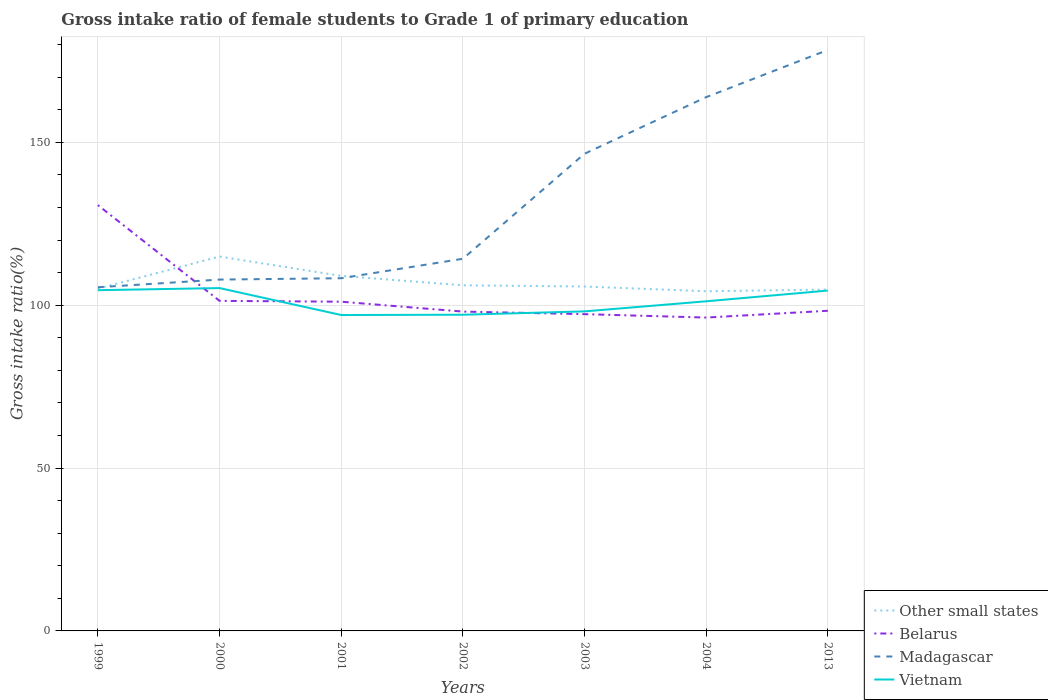How many different coloured lines are there?
Provide a succinct answer. 4. Does the line corresponding to Belarus intersect with the line corresponding to Other small states?
Make the answer very short. Yes. Across all years, what is the maximum gross intake ratio in Madagascar?
Offer a very short reply. 105.5. What is the total gross intake ratio in Vietnam in the graph?
Offer a very short reply. -4.12. What is the difference between the highest and the second highest gross intake ratio in Vietnam?
Your answer should be compact. 8.27. How many years are there in the graph?
Your response must be concise. 7. What is the difference between two consecutive major ticks on the Y-axis?
Offer a terse response. 50. Are the values on the major ticks of Y-axis written in scientific E-notation?
Keep it short and to the point. No. How many legend labels are there?
Keep it short and to the point. 4. What is the title of the graph?
Keep it short and to the point. Gross intake ratio of female students to Grade 1 of primary education. Does "Macao" appear as one of the legend labels in the graph?
Provide a short and direct response. No. What is the label or title of the X-axis?
Provide a short and direct response. Years. What is the label or title of the Y-axis?
Keep it short and to the point. Gross intake ratio(%). What is the Gross intake ratio(%) of Other small states in 1999?
Your answer should be very brief. 105.07. What is the Gross intake ratio(%) in Belarus in 1999?
Provide a succinct answer. 130.71. What is the Gross intake ratio(%) in Madagascar in 1999?
Give a very brief answer. 105.5. What is the Gross intake ratio(%) in Vietnam in 1999?
Your answer should be compact. 104.6. What is the Gross intake ratio(%) of Other small states in 2000?
Offer a very short reply. 114.93. What is the Gross intake ratio(%) in Belarus in 2000?
Give a very brief answer. 101.32. What is the Gross intake ratio(%) of Madagascar in 2000?
Provide a short and direct response. 107.85. What is the Gross intake ratio(%) of Vietnam in 2000?
Ensure brevity in your answer.  105.24. What is the Gross intake ratio(%) in Other small states in 2001?
Your answer should be very brief. 108.98. What is the Gross intake ratio(%) of Belarus in 2001?
Your answer should be compact. 101.06. What is the Gross intake ratio(%) in Madagascar in 2001?
Ensure brevity in your answer.  108.27. What is the Gross intake ratio(%) in Vietnam in 2001?
Your answer should be very brief. 96.98. What is the Gross intake ratio(%) of Other small states in 2002?
Your answer should be compact. 106.1. What is the Gross intake ratio(%) in Belarus in 2002?
Offer a very short reply. 98.03. What is the Gross intake ratio(%) of Madagascar in 2002?
Offer a very short reply. 114.24. What is the Gross intake ratio(%) of Vietnam in 2002?
Ensure brevity in your answer.  97.06. What is the Gross intake ratio(%) in Other small states in 2003?
Ensure brevity in your answer.  105.73. What is the Gross intake ratio(%) of Belarus in 2003?
Provide a short and direct response. 97.24. What is the Gross intake ratio(%) of Madagascar in 2003?
Give a very brief answer. 146.48. What is the Gross intake ratio(%) of Vietnam in 2003?
Your answer should be very brief. 98.09. What is the Gross intake ratio(%) of Other small states in 2004?
Ensure brevity in your answer.  104.27. What is the Gross intake ratio(%) of Belarus in 2004?
Ensure brevity in your answer.  96.19. What is the Gross intake ratio(%) of Madagascar in 2004?
Offer a very short reply. 163.85. What is the Gross intake ratio(%) of Vietnam in 2004?
Give a very brief answer. 101.19. What is the Gross intake ratio(%) of Other small states in 2013?
Ensure brevity in your answer.  104.79. What is the Gross intake ratio(%) in Belarus in 2013?
Provide a short and direct response. 98.28. What is the Gross intake ratio(%) in Madagascar in 2013?
Your answer should be very brief. 178.34. What is the Gross intake ratio(%) of Vietnam in 2013?
Offer a terse response. 104.48. Across all years, what is the maximum Gross intake ratio(%) of Other small states?
Ensure brevity in your answer.  114.93. Across all years, what is the maximum Gross intake ratio(%) in Belarus?
Your answer should be compact. 130.71. Across all years, what is the maximum Gross intake ratio(%) in Madagascar?
Your answer should be very brief. 178.34. Across all years, what is the maximum Gross intake ratio(%) in Vietnam?
Provide a short and direct response. 105.24. Across all years, what is the minimum Gross intake ratio(%) of Other small states?
Ensure brevity in your answer.  104.27. Across all years, what is the minimum Gross intake ratio(%) in Belarus?
Provide a succinct answer. 96.19. Across all years, what is the minimum Gross intake ratio(%) of Madagascar?
Keep it short and to the point. 105.5. Across all years, what is the minimum Gross intake ratio(%) of Vietnam?
Make the answer very short. 96.98. What is the total Gross intake ratio(%) in Other small states in the graph?
Your answer should be compact. 749.86. What is the total Gross intake ratio(%) of Belarus in the graph?
Offer a terse response. 722.84. What is the total Gross intake ratio(%) in Madagascar in the graph?
Offer a very short reply. 924.54. What is the total Gross intake ratio(%) in Vietnam in the graph?
Make the answer very short. 707.64. What is the difference between the Gross intake ratio(%) of Other small states in 1999 and that in 2000?
Offer a very short reply. -9.86. What is the difference between the Gross intake ratio(%) in Belarus in 1999 and that in 2000?
Provide a succinct answer. 29.39. What is the difference between the Gross intake ratio(%) in Madagascar in 1999 and that in 2000?
Your answer should be very brief. -2.36. What is the difference between the Gross intake ratio(%) in Vietnam in 1999 and that in 2000?
Offer a very short reply. -0.65. What is the difference between the Gross intake ratio(%) of Other small states in 1999 and that in 2001?
Your answer should be very brief. -3.91. What is the difference between the Gross intake ratio(%) of Belarus in 1999 and that in 2001?
Provide a short and direct response. 29.65. What is the difference between the Gross intake ratio(%) of Madagascar in 1999 and that in 2001?
Keep it short and to the point. -2.78. What is the difference between the Gross intake ratio(%) in Vietnam in 1999 and that in 2001?
Provide a short and direct response. 7.62. What is the difference between the Gross intake ratio(%) of Other small states in 1999 and that in 2002?
Give a very brief answer. -1.04. What is the difference between the Gross intake ratio(%) of Belarus in 1999 and that in 2002?
Your response must be concise. 32.69. What is the difference between the Gross intake ratio(%) in Madagascar in 1999 and that in 2002?
Make the answer very short. -8.75. What is the difference between the Gross intake ratio(%) in Vietnam in 1999 and that in 2002?
Offer a very short reply. 7.54. What is the difference between the Gross intake ratio(%) of Other small states in 1999 and that in 2003?
Ensure brevity in your answer.  -0.66. What is the difference between the Gross intake ratio(%) in Belarus in 1999 and that in 2003?
Give a very brief answer. 33.47. What is the difference between the Gross intake ratio(%) in Madagascar in 1999 and that in 2003?
Provide a short and direct response. -40.98. What is the difference between the Gross intake ratio(%) of Vietnam in 1999 and that in 2003?
Give a very brief answer. 6.51. What is the difference between the Gross intake ratio(%) of Other small states in 1999 and that in 2004?
Provide a succinct answer. 0.8. What is the difference between the Gross intake ratio(%) of Belarus in 1999 and that in 2004?
Your answer should be compact. 34.52. What is the difference between the Gross intake ratio(%) of Madagascar in 1999 and that in 2004?
Provide a short and direct response. -58.36. What is the difference between the Gross intake ratio(%) of Vietnam in 1999 and that in 2004?
Provide a short and direct response. 3.41. What is the difference between the Gross intake ratio(%) of Other small states in 1999 and that in 2013?
Ensure brevity in your answer.  0.28. What is the difference between the Gross intake ratio(%) in Belarus in 1999 and that in 2013?
Provide a short and direct response. 32.43. What is the difference between the Gross intake ratio(%) in Madagascar in 1999 and that in 2013?
Make the answer very short. -72.85. What is the difference between the Gross intake ratio(%) in Vietnam in 1999 and that in 2013?
Give a very brief answer. 0.12. What is the difference between the Gross intake ratio(%) of Other small states in 2000 and that in 2001?
Provide a succinct answer. 5.95. What is the difference between the Gross intake ratio(%) of Belarus in 2000 and that in 2001?
Give a very brief answer. 0.26. What is the difference between the Gross intake ratio(%) of Madagascar in 2000 and that in 2001?
Keep it short and to the point. -0.42. What is the difference between the Gross intake ratio(%) in Vietnam in 2000 and that in 2001?
Give a very brief answer. 8.27. What is the difference between the Gross intake ratio(%) of Other small states in 2000 and that in 2002?
Offer a very short reply. 8.83. What is the difference between the Gross intake ratio(%) in Belarus in 2000 and that in 2002?
Your answer should be very brief. 3.29. What is the difference between the Gross intake ratio(%) of Madagascar in 2000 and that in 2002?
Your answer should be very brief. -6.39. What is the difference between the Gross intake ratio(%) of Vietnam in 2000 and that in 2002?
Offer a very short reply. 8.18. What is the difference between the Gross intake ratio(%) of Other small states in 2000 and that in 2003?
Your response must be concise. 9.2. What is the difference between the Gross intake ratio(%) of Belarus in 2000 and that in 2003?
Your answer should be very brief. 4.08. What is the difference between the Gross intake ratio(%) of Madagascar in 2000 and that in 2003?
Your answer should be compact. -38.63. What is the difference between the Gross intake ratio(%) of Vietnam in 2000 and that in 2003?
Make the answer very short. 7.15. What is the difference between the Gross intake ratio(%) of Other small states in 2000 and that in 2004?
Offer a very short reply. 10.66. What is the difference between the Gross intake ratio(%) in Belarus in 2000 and that in 2004?
Offer a terse response. 5.13. What is the difference between the Gross intake ratio(%) of Madagascar in 2000 and that in 2004?
Give a very brief answer. -56. What is the difference between the Gross intake ratio(%) in Vietnam in 2000 and that in 2004?
Ensure brevity in your answer.  4.06. What is the difference between the Gross intake ratio(%) in Other small states in 2000 and that in 2013?
Ensure brevity in your answer.  10.14. What is the difference between the Gross intake ratio(%) of Belarus in 2000 and that in 2013?
Offer a terse response. 3.04. What is the difference between the Gross intake ratio(%) in Madagascar in 2000 and that in 2013?
Offer a terse response. -70.49. What is the difference between the Gross intake ratio(%) of Vietnam in 2000 and that in 2013?
Provide a short and direct response. 0.76. What is the difference between the Gross intake ratio(%) of Other small states in 2001 and that in 2002?
Give a very brief answer. 2.88. What is the difference between the Gross intake ratio(%) in Belarus in 2001 and that in 2002?
Give a very brief answer. 3.03. What is the difference between the Gross intake ratio(%) in Madagascar in 2001 and that in 2002?
Make the answer very short. -5.97. What is the difference between the Gross intake ratio(%) of Vietnam in 2001 and that in 2002?
Offer a terse response. -0.08. What is the difference between the Gross intake ratio(%) of Other small states in 2001 and that in 2003?
Your response must be concise. 3.25. What is the difference between the Gross intake ratio(%) in Belarus in 2001 and that in 2003?
Keep it short and to the point. 3.82. What is the difference between the Gross intake ratio(%) of Madagascar in 2001 and that in 2003?
Give a very brief answer. -38.21. What is the difference between the Gross intake ratio(%) in Vietnam in 2001 and that in 2003?
Your answer should be very brief. -1.11. What is the difference between the Gross intake ratio(%) of Other small states in 2001 and that in 2004?
Keep it short and to the point. 4.71. What is the difference between the Gross intake ratio(%) of Belarus in 2001 and that in 2004?
Your answer should be compact. 4.87. What is the difference between the Gross intake ratio(%) in Madagascar in 2001 and that in 2004?
Your answer should be compact. -55.58. What is the difference between the Gross intake ratio(%) in Vietnam in 2001 and that in 2004?
Give a very brief answer. -4.21. What is the difference between the Gross intake ratio(%) of Other small states in 2001 and that in 2013?
Keep it short and to the point. 4.19. What is the difference between the Gross intake ratio(%) of Belarus in 2001 and that in 2013?
Provide a succinct answer. 2.78. What is the difference between the Gross intake ratio(%) in Madagascar in 2001 and that in 2013?
Offer a very short reply. -70.07. What is the difference between the Gross intake ratio(%) in Vietnam in 2001 and that in 2013?
Give a very brief answer. -7.5. What is the difference between the Gross intake ratio(%) of Other small states in 2002 and that in 2003?
Provide a short and direct response. 0.38. What is the difference between the Gross intake ratio(%) of Belarus in 2002 and that in 2003?
Your answer should be very brief. 0.79. What is the difference between the Gross intake ratio(%) of Madagascar in 2002 and that in 2003?
Your response must be concise. -32.24. What is the difference between the Gross intake ratio(%) of Vietnam in 2002 and that in 2003?
Provide a short and direct response. -1.03. What is the difference between the Gross intake ratio(%) in Other small states in 2002 and that in 2004?
Your answer should be very brief. 1.83. What is the difference between the Gross intake ratio(%) in Belarus in 2002 and that in 2004?
Your response must be concise. 1.83. What is the difference between the Gross intake ratio(%) of Madagascar in 2002 and that in 2004?
Your response must be concise. -49.61. What is the difference between the Gross intake ratio(%) in Vietnam in 2002 and that in 2004?
Your answer should be compact. -4.12. What is the difference between the Gross intake ratio(%) in Other small states in 2002 and that in 2013?
Keep it short and to the point. 1.32. What is the difference between the Gross intake ratio(%) in Belarus in 2002 and that in 2013?
Offer a very short reply. -0.25. What is the difference between the Gross intake ratio(%) in Madagascar in 2002 and that in 2013?
Your response must be concise. -64.1. What is the difference between the Gross intake ratio(%) of Vietnam in 2002 and that in 2013?
Ensure brevity in your answer.  -7.42. What is the difference between the Gross intake ratio(%) of Other small states in 2003 and that in 2004?
Keep it short and to the point. 1.46. What is the difference between the Gross intake ratio(%) in Belarus in 2003 and that in 2004?
Give a very brief answer. 1.05. What is the difference between the Gross intake ratio(%) of Madagascar in 2003 and that in 2004?
Give a very brief answer. -17.37. What is the difference between the Gross intake ratio(%) in Vietnam in 2003 and that in 2004?
Provide a short and direct response. -3.1. What is the difference between the Gross intake ratio(%) of Other small states in 2003 and that in 2013?
Ensure brevity in your answer.  0.94. What is the difference between the Gross intake ratio(%) of Belarus in 2003 and that in 2013?
Keep it short and to the point. -1.04. What is the difference between the Gross intake ratio(%) of Madagascar in 2003 and that in 2013?
Keep it short and to the point. -31.86. What is the difference between the Gross intake ratio(%) of Vietnam in 2003 and that in 2013?
Your answer should be compact. -6.39. What is the difference between the Gross intake ratio(%) of Other small states in 2004 and that in 2013?
Your response must be concise. -0.52. What is the difference between the Gross intake ratio(%) of Belarus in 2004 and that in 2013?
Make the answer very short. -2.09. What is the difference between the Gross intake ratio(%) of Madagascar in 2004 and that in 2013?
Provide a succinct answer. -14.49. What is the difference between the Gross intake ratio(%) in Vietnam in 2004 and that in 2013?
Offer a very short reply. -3.29. What is the difference between the Gross intake ratio(%) in Other small states in 1999 and the Gross intake ratio(%) in Belarus in 2000?
Your response must be concise. 3.74. What is the difference between the Gross intake ratio(%) in Other small states in 1999 and the Gross intake ratio(%) in Madagascar in 2000?
Keep it short and to the point. -2.79. What is the difference between the Gross intake ratio(%) in Other small states in 1999 and the Gross intake ratio(%) in Vietnam in 2000?
Your response must be concise. -0.18. What is the difference between the Gross intake ratio(%) in Belarus in 1999 and the Gross intake ratio(%) in Madagascar in 2000?
Offer a terse response. 22.86. What is the difference between the Gross intake ratio(%) of Belarus in 1999 and the Gross intake ratio(%) of Vietnam in 2000?
Offer a terse response. 25.47. What is the difference between the Gross intake ratio(%) of Madagascar in 1999 and the Gross intake ratio(%) of Vietnam in 2000?
Give a very brief answer. 0.25. What is the difference between the Gross intake ratio(%) of Other small states in 1999 and the Gross intake ratio(%) of Belarus in 2001?
Offer a terse response. 4.01. What is the difference between the Gross intake ratio(%) of Other small states in 1999 and the Gross intake ratio(%) of Madagascar in 2001?
Provide a short and direct response. -3.21. What is the difference between the Gross intake ratio(%) in Other small states in 1999 and the Gross intake ratio(%) in Vietnam in 2001?
Ensure brevity in your answer.  8.09. What is the difference between the Gross intake ratio(%) of Belarus in 1999 and the Gross intake ratio(%) of Madagascar in 2001?
Your response must be concise. 22.44. What is the difference between the Gross intake ratio(%) in Belarus in 1999 and the Gross intake ratio(%) in Vietnam in 2001?
Your answer should be very brief. 33.74. What is the difference between the Gross intake ratio(%) in Madagascar in 1999 and the Gross intake ratio(%) in Vietnam in 2001?
Your answer should be compact. 8.52. What is the difference between the Gross intake ratio(%) of Other small states in 1999 and the Gross intake ratio(%) of Belarus in 2002?
Offer a terse response. 7.04. What is the difference between the Gross intake ratio(%) in Other small states in 1999 and the Gross intake ratio(%) in Madagascar in 2002?
Your response must be concise. -9.18. What is the difference between the Gross intake ratio(%) of Other small states in 1999 and the Gross intake ratio(%) of Vietnam in 2002?
Make the answer very short. 8. What is the difference between the Gross intake ratio(%) in Belarus in 1999 and the Gross intake ratio(%) in Madagascar in 2002?
Offer a terse response. 16.47. What is the difference between the Gross intake ratio(%) of Belarus in 1999 and the Gross intake ratio(%) of Vietnam in 2002?
Ensure brevity in your answer.  33.65. What is the difference between the Gross intake ratio(%) in Madagascar in 1999 and the Gross intake ratio(%) in Vietnam in 2002?
Your answer should be compact. 8.43. What is the difference between the Gross intake ratio(%) of Other small states in 1999 and the Gross intake ratio(%) of Belarus in 2003?
Your answer should be compact. 7.83. What is the difference between the Gross intake ratio(%) in Other small states in 1999 and the Gross intake ratio(%) in Madagascar in 2003?
Provide a succinct answer. -41.41. What is the difference between the Gross intake ratio(%) of Other small states in 1999 and the Gross intake ratio(%) of Vietnam in 2003?
Provide a short and direct response. 6.98. What is the difference between the Gross intake ratio(%) in Belarus in 1999 and the Gross intake ratio(%) in Madagascar in 2003?
Offer a very short reply. -15.77. What is the difference between the Gross intake ratio(%) of Belarus in 1999 and the Gross intake ratio(%) of Vietnam in 2003?
Make the answer very short. 32.62. What is the difference between the Gross intake ratio(%) in Madagascar in 1999 and the Gross intake ratio(%) in Vietnam in 2003?
Offer a terse response. 7.4. What is the difference between the Gross intake ratio(%) of Other small states in 1999 and the Gross intake ratio(%) of Belarus in 2004?
Make the answer very short. 8.87. What is the difference between the Gross intake ratio(%) in Other small states in 1999 and the Gross intake ratio(%) in Madagascar in 2004?
Offer a terse response. -58.79. What is the difference between the Gross intake ratio(%) of Other small states in 1999 and the Gross intake ratio(%) of Vietnam in 2004?
Offer a very short reply. 3.88. What is the difference between the Gross intake ratio(%) of Belarus in 1999 and the Gross intake ratio(%) of Madagascar in 2004?
Offer a terse response. -33.14. What is the difference between the Gross intake ratio(%) in Belarus in 1999 and the Gross intake ratio(%) in Vietnam in 2004?
Your answer should be very brief. 29.53. What is the difference between the Gross intake ratio(%) in Madagascar in 1999 and the Gross intake ratio(%) in Vietnam in 2004?
Give a very brief answer. 4.31. What is the difference between the Gross intake ratio(%) of Other small states in 1999 and the Gross intake ratio(%) of Belarus in 2013?
Give a very brief answer. 6.79. What is the difference between the Gross intake ratio(%) of Other small states in 1999 and the Gross intake ratio(%) of Madagascar in 2013?
Your answer should be very brief. -73.28. What is the difference between the Gross intake ratio(%) of Other small states in 1999 and the Gross intake ratio(%) of Vietnam in 2013?
Keep it short and to the point. 0.59. What is the difference between the Gross intake ratio(%) of Belarus in 1999 and the Gross intake ratio(%) of Madagascar in 2013?
Offer a terse response. -47.63. What is the difference between the Gross intake ratio(%) of Belarus in 1999 and the Gross intake ratio(%) of Vietnam in 2013?
Make the answer very short. 26.23. What is the difference between the Gross intake ratio(%) of Madagascar in 1999 and the Gross intake ratio(%) of Vietnam in 2013?
Give a very brief answer. 1.02. What is the difference between the Gross intake ratio(%) of Other small states in 2000 and the Gross intake ratio(%) of Belarus in 2001?
Provide a succinct answer. 13.87. What is the difference between the Gross intake ratio(%) of Other small states in 2000 and the Gross intake ratio(%) of Madagascar in 2001?
Your answer should be compact. 6.66. What is the difference between the Gross intake ratio(%) of Other small states in 2000 and the Gross intake ratio(%) of Vietnam in 2001?
Make the answer very short. 17.95. What is the difference between the Gross intake ratio(%) in Belarus in 2000 and the Gross intake ratio(%) in Madagascar in 2001?
Provide a succinct answer. -6.95. What is the difference between the Gross intake ratio(%) of Belarus in 2000 and the Gross intake ratio(%) of Vietnam in 2001?
Give a very brief answer. 4.34. What is the difference between the Gross intake ratio(%) of Madagascar in 2000 and the Gross intake ratio(%) of Vietnam in 2001?
Provide a succinct answer. 10.88. What is the difference between the Gross intake ratio(%) in Other small states in 2000 and the Gross intake ratio(%) in Belarus in 2002?
Your answer should be very brief. 16.9. What is the difference between the Gross intake ratio(%) of Other small states in 2000 and the Gross intake ratio(%) of Madagascar in 2002?
Make the answer very short. 0.69. What is the difference between the Gross intake ratio(%) in Other small states in 2000 and the Gross intake ratio(%) in Vietnam in 2002?
Your answer should be very brief. 17.87. What is the difference between the Gross intake ratio(%) in Belarus in 2000 and the Gross intake ratio(%) in Madagascar in 2002?
Your answer should be very brief. -12.92. What is the difference between the Gross intake ratio(%) in Belarus in 2000 and the Gross intake ratio(%) in Vietnam in 2002?
Offer a very short reply. 4.26. What is the difference between the Gross intake ratio(%) in Madagascar in 2000 and the Gross intake ratio(%) in Vietnam in 2002?
Provide a succinct answer. 10.79. What is the difference between the Gross intake ratio(%) of Other small states in 2000 and the Gross intake ratio(%) of Belarus in 2003?
Offer a very short reply. 17.69. What is the difference between the Gross intake ratio(%) in Other small states in 2000 and the Gross intake ratio(%) in Madagascar in 2003?
Offer a terse response. -31.55. What is the difference between the Gross intake ratio(%) of Other small states in 2000 and the Gross intake ratio(%) of Vietnam in 2003?
Give a very brief answer. 16.84. What is the difference between the Gross intake ratio(%) in Belarus in 2000 and the Gross intake ratio(%) in Madagascar in 2003?
Provide a succinct answer. -45.16. What is the difference between the Gross intake ratio(%) of Belarus in 2000 and the Gross intake ratio(%) of Vietnam in 2003?
Your response must be concise. 3.23. What is the difference between the Gross intake ratio(%) in Madagascar in 2000 and the Gross intake ratio(%) in Vietnam in 2003?
Make the answer very short. 9.76. What is the difference between the Gross intake ratio(%) in Other small states in 2000 and the Gross intake ratio(%) in Belarus in 2004?
Provide a succinct answer. 18.74. What is the difference between the Gross intake ratio(%) in Other small states in 2000 and the Gross intake ratio(%) in Madagascar in 2004?
Your response must be concise. -48.92. What is the difference between the Gross intake ratio(%) in Other small states in 2000 and the Gross intake ratio(%) in Vietnam in 2004?
Give a very brief answer. 13.74. What is the difference between the Gross intake ratio(%) in Belarus in 2000 and the Gross intake ratio(%) in Madagascar in 2004?
Offer a terse response. -62.53. What is the difference between the Gross intake ratio(%) in Belarus in 2000 and the Gross intake ratio(%) in Vietnam in 2004?
Give a very brief answer. 0.14. What is the difference between the Gross intake ratio(%) in Madagascar in 2000 and the Gross intake ratio(%) in Vietnam in 2004?
Your answer should be compact. 6.67. What is the difference between the Gross intake ratio(%) in Other small states in 2000 and the Gross intake ratio(%) in Belarus in 2013?
Your response must be concise. 16.65. What is the difference between the Gross intake ratio(%) of Other small states in 2000 and the Gross intake ratio(%) of Madagascar in 2013?
Your answer should be compact. -63.41. What is the difference between the Gross intake ratio(%) in Other small states in 2000 and the Gross intake ratio(%) in Vietnam in 2013?
Offer a terse response. 10.45. What is the difference between the Gross intake ratio(%) in Belarus in 2000 and the Gross intake ratio(%) in Madagascar in 2013?
Give a very brief answer. -77.02. What is the difference between the Gross intake ratio(%) of Belarus in 2000 and the Gross intake ratio(%) of Vietnam in 2013?
Your response must be concise. -3.16. What is the difference between the Gross intake ratio(%) of Madagascar in 2000 and the Gross intake ratio(%) of Vietnam in 2013?
Your response must be concise. 3.37. What is the difference between the Gross intake ratio(%) of Other small states in 2001 and the Gross intake ratio(%) of Belarus in 2002?
Your answer should be very brief. 10.95. What is the difference between the Gross intake ratio(%) of Other small states in 2001 and the Gross intake ratio(%) of Madagascar in 2002?
Offer a terse response. -5.26. What is the difference between the Gross intake ratio(%) of Other small states in 2001 and the Gross intake ratio(%) of Vietnam in 2002?
Offer a terse response. 11.92. What is the difference between the Gross intake ratio(%) of Belarus in 2001 and the Gross intake ratio(%) of Madagascar in 2002?
Your answer should be compact. -13.18. What is the difference between the Gross intake ratio(%) of Belarus in 2001 and the Gross intake ratio(%) of Vietnam in 2002?
Provide a short and direct response. 4. What is the difference between the Gross intake ratio(%) in Madagascar in 2001 and the Gross intake ratio(%) in Vietnam in 2002?
Your response must be concise. 11.21. What is the difference between the Gross intake ratio(%) of Other small states in 2001 and the Gross intake ratio(%) of Belarus in 2003?
Give a very brief answer. 11.74. What is the difference between the Gross intake ratio(%) of Other small states in 2001 and the Gross intake ratio(%) of Madagascar in 2003?
Ensure brevity in your answer.  -37.5. What is the difference between the Gross intake ratio(%) of Other small states in 2001 and the Gross intake ratio(%) of Vietnam in 2003?
Make the answer very short. 10.89. What is the difference between the Gross intake ratio(%) of Belarus in 2001 and the Gross intake ratio(%) of Madagascar in 2003?
Give a very brief answer. -45.42. What is the difference between the Gross intake ratio(%) of Belarus in 2001 and the Gross intake ratio(%) of Vietnam in 2003?
Keep it short and to the point. 2.97. What is the difference between the Gross intake ratio(%) of Madagascar in 2001 and the Gross intake ratio(%) of Vietnam in 2003?
Keep it short and to the point. 10.18. What is the difference between the Gross intake ratio(%) of Other small states in 2001 and the Gross intake ratio(%) of Belarus in 2004?
Provide a succinct answer. 12.79. What is the difference between the Gross intake ratio(%) in Other small states in 2001 and the Gross intake ratio(%) in Madagascar in 2004?
Your answer should be compact. -54.87. What is the difference between the Gross intake ratio(%) of Other small states in 2001 and the Gross intake ratio(%) of Vietnam in 2004?
Offer a very short reply. 7.79. What is the difference between the Gross intake ratio(%) in Belarus in 2001 and the Gross intake ratio(%) in Madagascar in 2004?
Offer a very short reply. -62.79. What is the difference between the Gross intake ratio(%) of Belarus in 2001 and the Gross intake ratio(%) of Vietnam in 2004?
Give a very brief answer. -0.13. What is the difference between the Gross intake ratio(%) of Madagascar in 2001 and the Gross intake ratio(%) of Vietnam in 2004?
Ensure brevity in your answer.  7.09. What is the difference between the Gross intake ratio(%) in Other small states in 2001 and the Gross intake ratio(%) in Belarus in 2013?
Your response must be concise. 10.7. What is the difference between the Gross intake ratio(%) in Other small states in 2001 and the Gross intake ratio(%) in Madagascar in 2013?
Give a very brief answer. -69.36. What is the difference between the Gross intake ratio(%) in Other small states in 2001 and the Gross intake ratio(%) in Vietnam in 2013?
Offer a terse response. 4.5. What is the difference between the Gross intake ratio(%) of Belarus in 2001 and the Gross intake ratio(%) of Madagascar in 2013?
Give a very brief answer. -77.28. What is the difference between the Gross intake ratio(%) in Belarus in 2001 and the Gross intake ratio(%) in Vietnam in 2013?
Offer a terse response. -3.42. What is the difference between the Gross intake ratio(%) in Madagascar in 2001 and the Gross intake ratio(%) in Vietnam in 2013?
Ensure brevity in your answer.  3.79. What is the difference between the Gross intake ratio(%) in Other small states in 2002 and the Gross intake ratio(%) in Belarus in 2003?
Make the answer very short. 8.86. What is the difference between the Gross intake ratio(%) of Other small states in 2002 and the Gross intake ratio(%) of Madagascar in 2003?
Ensure brevity in your answer.  -40.38. What is the difference between the Gross intake ratio(%) in Other small states in 2002 and the Gross intake ratio(%) in Vietnam in 2003?
Offer a terse response. 8.01. What is the difference between the Gross intake ratio(%) in Belarus in 2002 and the Gross intake ratio(%) in Madagascar in 2003?
Make the answer very short. -48.45. What is the difference between the Gross intake ratio(%) of Belarus in 2002 and the Gross intake ratio(%) of Vietnam in 2003?
Your answer should be very brief. -0.06. What is the difference between the Gross intake ratio(%) in Madagascar in 2002 and the Gross intake ratio(%) in Vietnam in 2003?
Your answer should be compact. 16.15. What is the difference between the Gross intake ratio(%) in Other small states in 2002 and the Gross intake ratio(%) in Belarus in 2004?
Your answer should be compact. 9.91. What is the difference between the Gross intake ratio(%) of Other small states in 2002 and the Gross intake ratio(%) of Madagascar in 2004?
Provide a short and direct response. -57.75. What is the difference between the Gross intake ratio(%) of Other small states in 2002 and the Gross intake ratio(%) of Vietnam in 2004?
Ensure brevity in your answer.  4.92. What is the difference between the Gross intake ratio(%) of Belarus in 2002 and the Gross intake ratio(%) of Madagascar in 2004?
Offer a terse response. -65.82. What is the difference between the Gross intake ratio(%) in Belarus in 2002 and the Gross intake ratio(%) in Vietnam in 2004?
Make the answer very short. -3.16. What is the difference between the Gross intake ratio(%) in Madagascar in 2002 and the Gross intake ratio(%) in Vietnam in 2004?
Offer a very short reply. 13.06. What is the difference between the Gross intake ratio(%) of Other small states in 2002 and the Gross intake ratio(%) of Belarus in 2013?
Offer a very short reply. 7.82. What is the difference between the Gross intake ratio(%) in Other small states in 2002 and the Gross intake ratio(%) in Madagascar in 2013?
Give a very brief answer. -72.24. What is the difference between the Gross intake ratio(%) in Other small states in 2002 and the Gross intake ratio(%) in Vietnam in 2013?
Ensure brevity in your answer.  1.62. What is the difference between the Gross intake ratio(%) in Belarus in 2002 and the Gross intake ratio(%) in Madagascar in 2013?
Provide a short and direct response. -80.31. What is the difference between the Gross intake ratio(%) in Belarus in 2002 and the Gross intake ratio(%) in Vietnam in 2013?
Provide a short and direct response. -6.45. What is the difference between the Gross intake ratio(%) in Madagascar in 2002 and the Gross intake ratio(%) in Vietnam in 2013?
Ensure brevity in your answer.  9.76. What is the difference between the Gross intake ratio(%) in Other small states in 2003 and the Gross intake ratio(%) in Belarus in 2004?
Make the answer very short. 9.53. What is the difference between the Gross intake ratio(%) in Other small states in 2003 and the Gross intake ratio(%) in Madagascar in 2004?
Offer a terse response. -58.13. What is the difference between the Gross intake ratio(%) in Other small states in 2003 and the Gross intake ratio(%) in Vietnam in 2004?
Keep it short and to the point. 4.54. What is the difference between the Gross intake ratio(%) in Belarus in 2003 and the Gross intake ratio(%) in Madagascar in 2004?
Keep it short and to the point. -66.61. What is the difference between the Gross intake ratio(%) of Belarus in 2003 and the Gross intake ratio(%) of Vietnam in 2004?
Keep it short and to the point. -3.95. What is the difference between the Gross intake ratio(%) of Madagascar in 2003 and the Gross intake ratio(%) of Vietnam in 2004?
Give a very brief answer. 45.29. What is the difference between the Gross intake ratio(%) of Other small states in 2003 and the Gross intake ratio(%) of Belarus in 2013?
Offer a very short reply. 7.45. What is the difference between the Gross intake ratio(%) in Other small states in 2003 and the Gross intake ratio(%) in Madagascar in 2013?
Provide a succinct answer. -72.62. What is the difference between the Gross intake ratio(%) in Other small states in 2003 and the Gross intake ratio(%) in Vietnam in 2013?
Ensure brevity in your answer.  1.25. What is the difference between the Gross intake ratio(%) of Belarus in 2003 and the Gross intake ratio(%) of Madagascar in 2013?
Keep it short and to the point. -81.1. What is the difference between the Gross intake ratio(%) in Belarus in 2003 and the Gross intake ratio(%) in Vietnam in 2013?
Provide a succinct answer. -7.24. What is the difference between the Gross intake ratio(%) of Madagascar in 2003 and the Gross intake ratio(%) of Vietnam in 2013?
Your answer should be compact. 42. What is the difference between the Gross intake ratio(%) in Other small states in 2004 and the Gross intake ratio(%) in Belarus in 2013?
Provide a short and direct response. 5.99. What is the difference between the Gross intake ratio(%) in Other small states in 2004 and the Gross intake ratio(%) in Madagascar in 2013?
Keep it short and to the point. -74.07. What is the difference between the Gross intake ratio(%) in Other small states in 2004 and the Gross intake ratio(%) in Vietnam in 2013?
Provide a short and direct response. -0.21. What is the difference between the Gross intake ratio(%) in Belarus in 2004 and the Gross intake ratio(%) in Madagascar in 2013?
Give a very brief answer. -82.15. What is the difference between the Gross intake ratio(%) in Belarus in 2004 and the Gross intake ratio(%) in Vietnam in 2013?
Your answer should be compact. -8.29. What is the difference between the Gross intake ratio(%) in Madagascar in 2004 and the Gross intake ratio(%) in Vietnam in 2013?
Offer a very short reply. 59.37. What is the average Gross intake ratio(%) of Other small states per year?
Your answer should be compact. 107.12. What is the average Gross intake ratio(%) in Belarus per year?
Offer a terse response. 103.26. What is the average Gross intake ratio(%) of Madagascar per year?
Provide a succinct answer. 132.08. What is the average Gross intake ratio(%) of Vietnam per year?
Your answer should be very brief. 101.09. In the year 1999, what is the difference between the Gross intake ratio(%) of Other small states and Gross intake ratio(%) of Belarus?
Ensure brevity in your answer.  -25.65. In the year 1999, what is the difference between the Gross intake ratio(%) of Other small states and Gross intake ratio(%) of Madagascar?
Ensure brevity in your answer.  -0.43. In the year 1999, what is the difference between the Gross intake ratio(%) in Other small states and Gross intake ratio(%) in Vietnam?
Keep it short and to the point. 0.47. In the year 1999, what is the difference between the Gross intake ratio(%) of Belarus and Gross intake ratio(%) of Madagascar?
Your response must be concise. 25.22. In the year 1999, what is the difference between the Gross intake ratio(%) of Belarus and Gross intake ratio(%) of Vietnam?
Your answer should be very brief. 26.12. In the year 1999, what is the difference between the Gross intake ratio(%) of Madagascar and Gross intake ratio(%) of Vietnam?
Give a very brief answer. 0.9. In the year 2000, what is the difference between the Gross intake ratio(%) in Other small states and Gross intake ratio(%) in Belarus?
Ensure brevity in your answer.  13.61. In the year 2000, what is the difference between the Gross intake ratio(%) of Other small states and Gross intake ratio(%) of Madagascar?
Your response must be concise. 7.08. In the year 2000, what is the difference between the Gross intake ratio(%) in Other small states and Gross intake ratio(%) in Vietnam?
Your answer should be compact. 9.69. In the year 2000, what is the difference between the Gross intake ratio(%) in Belarus and Gross intake ratio(%) in Madagascar?
Your response must be concise. -6.53. In the year 2000, what is the difference between the Gross intake ratio(%) in Belarus and Gross intake ratio(%) in Vietnam?
Offer a terse response. -3.92. In the year 2000, what is the difference between the Gross intake ratio(%) in Madagascar and Gross intake ratio(%) in Vietnam?
Keep it short and to the point. 2.61. In the year 2001, what is the difference between the Gross intake ratio(%) in Other small states and Gross intake ratio(%) in Belarus?
Make the answer very short. 7.92. In the year 2001, what is the difference between the Gross intake ratio(%) in Other small states and Gross intake ratio(%) in Madagascar?
Provide a succinct answer. 0.71. In the year 2001, what is the difference between the Gross intake ratio(%) of Other small states and Gross intake ratio(%) of Vietnam?
Provide a short and direct response. 12. In the year 2001, what is the difference between the Gross intake ratio(%) in Belarus and Gross intake ratio(%) in Madagascar?
Your answer should be very brief. -7.21. In the year 2001, what is the difference between the Gross intake ratio(%) in Belarus and Gross intake ratio(%) in Vietnam?
Keep it short and to the point. 4.08. In the year 2001, what is the difference between the Gross intake ratio(%) in Madagascar and Gross intake ratio(%) in Vietnam?
Your response must be concise. 11.29. In the year 2002, what is the difference between the Gross intake ratio(%) of Other small states and Gross intake ratio(%) of Belarus?
Your response must be concise. 8.07. In the year 2002, what is the difference between the Gross intake ratio(%) of Other small states and Gross intake ratio(%) of Madagascar?
Make the answer very short. -8.14. In the year 2002, what is the difference between the Gross intake ratio(%) in Other small states and Gross intake ratio(%) in Vietnam?
Give a very brief answer. 9.04. In the year 2002, what is the difference between the Gross intake ratio(%) of Belarus and Gross intake ratio(%) of Madagascar?
Give a very brief answer. -16.22. In the year 2002, what is the difference between the Gross intake ratio(%) of Belarus and Gross intake ratio(%) of Vietnam?
Your answer should be compact. 0.97. In the year 2002, what is the difference between the Gross intake ratio(%) of Madagascar and Gross intake ratio(%) of Vietnam?
Keep it short and to the point. 17.18. In the year 2003, what is the difference between the Gross intake ratio(%) of Other small states and Gross intake ratio(%) of Belarus?
Your response must be concise. 8.48. In the year 2003, what is the difference between the Gross intake ratio(%) of Other small states and Gross intake ratio(%) of Madagascar?
Ensure brevity in your answer.  -40.75. In the year 2003, what is the difference between the Gross intake ratio(%) of Other small states and Gross intake ratio(%) of Vietnam?
Provide a short and direct response. 7.64. In the year 2003, what is the difference between the Gross intake ratio(%) of Belarus and Gross intake ratio(%) of Madagascar?
Provide a succinct answer. -49.24. In the year 2003, what is the difference between the Gross intake ratio(%) in Belarus and Gross intake ratio(%) in Vietnam?
Ensure brevity in your answer.  -0.85. In the year 2003, what is the difference between the Gross intake ratio(%) in Madagascar and Gross intake ratio(%) in Vietnam?
Provide a succinct answer. 48.39. In the year 2004, what is the difference between the Gross intake ratio(%) of Other small states and Gross intake ratio(%) of Belarus?
Make the answer very short. 8.08. In the year 2004, what is the difference between the Gross intake ratio(%) of Other small states and Gross intake ratio(%) of Madagascar?
Make the answer very short. -59.58. In the year 2004, what is the difference between the Gross intake ratio(%) in Other small states and Gross intake ratio(%) in Vietnam?
Provide a succinct answer. 3.08. In the year 2004, what is the difference between the Gross intake ratio(%) of Belarus and Gross intake ratio(%) of Madagascar?
Ensure brevity in your answer.  -67.66. In the year 2004, what is the difference between the Gross intake ratio(%) of Belarus and Gross intake ratio(%) of Vietnam?
Your answer should be compact. -4.99. In the year 2004, what is the difference between the Gross intake ratio(%) in Madagascar and Gross intake ratio(%) in Vietnam?
Provide a succinct answer. 62.67. In the year 2013, what is the difference between the Gross intake ratio(%) of Other small states and Gross intake ratio(%) of Belarus?
Your answer should be very brief. 6.51. In the year 2013, what is the difference between the Gross intake ratio(%) of Other small states and Gross intake ratio(%) of Madagascar?
Give a very brief answer. -73.56. In the year 2013, what is the difference between the Gross intake ratio(%) in Other small states and Gross intake ratio(%) in Vietnam?
Your response must be concise. 0.31. In the year 2013, what is the difference between the Gross intake ratio(%) in Belarus and Gross intake ratio(%) in Madagascar?
Offer a very short reply. -80.06. In the year 2013, what is the difference between the Gross intake ratio(%) of Belarus and Gross intake ratio(%) of Vietnam?
Provide a short and direct response. -6.2. In the year 2013, what is the difference between the Gross intake ratio(%) in Madagascar and Gross intake ratio(%) in Vietnam?
Give a very brief answer. 73.86. What is the ratio of the Gross intake ratio(%) of Other small states in 1999 to that in 2000?
Ensure brevity in your answer.  0.91. What is the ratio of the Gross intake ratio(%) of Belarus in 1999 to that in 2000?
Offer a terse response. 1.29. What is the ratio of the Gross intake ratio(%) of Madagascar in 1999 to that in 2000?
Ensure brevity in your answer.  0.98. What is the ratio of the Gross intake ratio(%) of Other small states in 1999 to that in 2001?
Provide a succinct answer. 0.96. What is the ratio of the Gross intake ratio(%) of Belarus in 1999 to that in 2001?
Ensure brevity in your answer.  1.29. What is the ratio of the Gross intake ratio(%) in Madagascar in 1999 to that in 2001?
Make the answer very short. 0.97. What is the ratio of the Gross intake ratio(%) of Vietnam in 1999 to that in 2001?
Your answer should be very brief. 1.08. What is the ratio of the Gross intake ratio(%) of Other small states in 1999 to that in 2002?
Ensure brevity in your answer.  0.99. What is the ratio of the Gross intake ratio(%) in Belarus in 1999 to that in 2002?
Offer a very short reply. 1.33. What is the ratio of the Gross intake ratio(%) in Madagascar in 1999 to that in 2002?
Offer a very short reply. 0.92. What is the ratio of the Gross intake ratio(%) in Vietnam in 1999 to that in 2002?
Provide a short and direct response. 1.08. What is the ratio of the Gross intake ratio(%) in Other small states in 1999 to that in 2003?
Provide a succinct answer. 0.99. What is the ratio of the Gross intake ratio(%) in Belarus in 1999 to that in 2003?
Offer a very short reply. 1.34. What is the ratio of the Gross intake ratio(%) of Madagascar in 1999 to that in 2003?
Offer a very short reply. 0.72. What is the ratio of the Gross intake ratio(%) of Vietnam in 1999 to that in 2003?
Ensure brevity in your answer.  1.07. What is the ratio of the Gross intake ratio(%) of Other small states in 1999 to that in 2004?
Ensure brevity in your answer.  1.01. What is the ratio of the Gross intake ratio(%) of Belarus in 1999 to that in 2004?
Ensure brevity in your answer.  1.36. What is the ratio of the Gross intake ratio(%) in Madagascar in 1999 to that in 2004?
Provide a succinct answer. 0.64. What is the ratio of the Gross intake ratio(%) of Vietnam in 1999 to that in 2004?
Your answer should be compact. 1.03. What is the ratio of the Gross intake ratio(%) in Belarus in 1999 to that in 2013?
Your answer should be compact. 1.33. What is the ratio of the Gross intake ratio(%) of Madagascar in 1999 to that in 2013?
Your answer should be very brief. 0.59. What is the ratio of the Gross intake ratio(%) of Vietnam in 1999 to that in 2013?
Offer a very short reply. 1. What is the ratio of the Gross intake ratio(%) in Other small states in 2000 to that in 2001?
Provide a succinct answer. 1.05. What is the ratio of the Gross intake ratio(%) of Madagascar in 2000 to that in 2001?
Your answer should be very brief. 1. What is the ratio of the Gross intake ratio(%) of Vietnam in 2000 to that in 2001?
Provide a short and direct response. 1.09. What is the ratio of the Gross intake ratio(%) of Other small states in 2000 to that in 2002?
Provide a succinct answer. 1.08. What is the ratio of the Gross intake ratio(%) in Belarus in 2000 to that in 2002?
Provide a succinct answer. 1.03. What is the ratio of the Gross intake ratio(%) in Madagascar in 2000 to that in 2002?
Offer a terse response. 0.94. What is the ratio of the Gross intake ratio(%) in Vietnam in 2000 to that in 2002?
Provide a succinct answer. 1.08. What is the ratio of the Gross intake ratio(%) of Other small states in 2000 to that in 2003?
Provide a short and direct response. 1.09. What is the ratio of the Gross intake ratio(%) of Belarus in 2000 to that in 2003?
Keep it short and to the point. 1.04. What is the ratio of the Gross intake ratio(%) of Madagascar in 2000 to that in 2003?
Your answer should be compact. 0.74. What is the ratio of the Gross intake ratio(%) of Vietnam in 2000 to that in 2003?
Provide a succinct answer. 1.07. What is the ratio of the Gross intake ratio(%) in Other small states in 2000 to that in 2004?
Your answer should be compact. 1.1. What is the ratio of the Gross intake ratio(%) in Belarus in 2000 to that in 2004?
Keep it short and to the point. 1.05. What is the ratio of the Gross intake ratio(%) in Madagascar in 2000 to that in 2004?
Your answer should be very brief. 0.66. What is the ratio of the Gross intake ratio(%) in Vietnam in 2000 to that in 2004?
Offer a very short reply. 1.04. What is the ratio of the Gross intake ratio(%) of Other small states in 2000 to that in 2013?
Provide a succinct answer. 1.1. What is the ratio of the Gross intake ratio(%) in Belarus in 2000 to that in 2013?
Offer a terse response. 1.03. What is the ratio of the Gross intake ratio(%) of Madagascar in 2000 to that in 2013?
Provide a short and direct response. 0.6. What is the ratio of the Gross intake ratio(%) of Vietnam in 2000 to that in 2013?
Your answer should be compact. 1.01. What is the ratio of the Gross intake ratio(%) in Other small states in 2001 to that in 2002?
Provide a succinct answer. 1.03. What is the ratio of the Gross intake ratio(%) in Belarus in 2001 to that in 2002?
Make the answer very short. 1.03. What is the ratio of the Gross intake ratio(%) in Madagascar in 2001 to that in 2002?
Provide a short and direct response. 0.95. What is the ratio of the Gross intake ratio(%) of Vietnam in 2001 to that in 2002?
Your response must be concise. 1. What is the ratio of the Gross intake ratio(%) of Other small states in 2001 to that in 2003?
Your answer should be compact. 1.03. What is the ratio of the Gross intake ratio(%) of Belarus in 2001 to that in 2003?
Offer a terse response. 1.04. What is the ratio of the Gross intake ratio(%) in Madagascar in 2001 to that in 2003?
Keep it short and to the point. 0.74. What is the ratio of the Gross intake ratio(%) in Vietnam in 2001 to that in 2003?
Your answer should be compact. 0.99. What is the ratio of the Gross intake ratio(%) of Other small states in 2001 to that in 2004?
Give a very brief answer. 1.05. What is the ratio of the Gross intake ratio(%) in Belarus in 2001 to that in 2004?
Your answer should be compact. 1.05. What is the ratio of the Gross intake ratio(%) of Madagascar in 2001 to that in 2004?
Provide a succinct answer. 0.66. What is the ratio of the Gross intake ratio(%) in Vietnam in 2001 to that in 2004?
Keep it short and to the point. 0.96. What is the ratio of the Gross intake ratio(%) of Belarus in 2001 to that in 2013?
Provide a short and direct response. 1.03. What is the ratio of the Gross intake ratio(%) of Madagascar in 2001 to that in 2013?
Offer a terse response. 0.61. What is the ratio of the Gross intake ratio(%) in Vietnam in 2001 to that in 2013?
Your answer should be very brief. 0.93. What is the ratio of the Gross intake ratio(%) of Belarus in 2002 to that in 2003?
Your answer should be compact. 1.01. What is the ratio of the Gross intake ratio(%) of Madagascar in 2002 to that in 2003?
Your response must be concise. 0.78. What is the ratio of the Gross intake ratio(%) in Vietnam in 2002 to that in 2003?
Offer a very short reply. 0.99. What is the ratio of the Gross intake ratio(%) of Other small states in 2002 to that in 2004?
Your response must be concise. 1.02. What is the ratio of the Gross intake ratio(%) in Belarus in 2002 to that in 2004?
Offer a very short reply. 1.02. What is the ratio of the Gross intake ratio(%) in Madagascar in 2002 to that in 2004?
Give a very brief answer. 0.7. What is the ratio of the Gross intake ratio(%) in Vietnam in 2002 to that in 2004?
Ensure brevity in your answer.  0.96. What is the ratio of the Gross intake ratio(%) of Other small states in 2002 to that in 2013?
Keep it short and to the point. 1.01. What is the ratio of the Gross intake ratio(%) of Madagascar in 2002 to that in 2013?
Ensure brevity in your answer.  0.64. What is the ratio of the Gross intake ratio(%) of Vietnam in 2002 to that in 2013?
Offer a terse response. 0.93. What is the ratio of the Gross intake ratio(%) in Belarus in 2003 to that in 2004?
Make the answer very short. 1.01. What is the ratio of the Gross intake ratio(%) in Madagascar in 2003 to that in 2004?
Offer a terse response. 0.89. What is the ratio of the Gross intake ratio(%) of Vietnam in 2003 to that in 2004?
Your answer should be compact. 0.97. What is the ratio of the Gross intake ratio(%) in Other small states in 2003 to that in 2013?
Offer a terse response. 1.01. What is the ratio of the Gross intake ratio(%) in Belarus in 2003 to that in 2013?
Offer a very short reply. 0.99. What is the ratio of the Gross intake ratio(%) in Madagascar in 2003 to that in 2013?
Give a very brief answer. 0.82. What is the ratio of the Gross intake ratio(%) in Vietnam in 2003 to that in 2013?
Provide a succinct answer. 0.94. What is the ratio of the Gross intake ratio(%) of Belarus in 2004 to that in 2013?
Give a very brief answer. 0.98. What is the ratio of the Gross intake ratio(%) of Madagascar in 2004 to that in 2013?
Your answer should be very brief. 0.92. What is the ratio of the Gross intake ratio(%) of Vietnam in 2004 to that in 2013?
Offer a terse response. 0.97. What is the difference between the highest and the second highest Gross intake ratio(%) in Other small states?
Your response must be concise. 5.95. What is the difference between the highest and the second highest Gross intake ratio(%) of Belarus?
Your response must be concise. 29.39. What is the difference between the highest and the second highest Gross intake ratio(%) of Madagascar?
Give a very brief answer. 14.49. What is the difference between the highest and the second highest Gross intake ratio(%) in Vietnam?
Make the answer very short. 0.65. What is the difference between the highest and the lowest Gross intake ratio(%) in Other small states?
Give a very brief answer. 10.66. What is the difference between the highest and the lowest Gross intake ratio(%) in Belarus?
Offer a terse response. 34.52. What is the difference between the highest and the lowest Gross intake ratio(%) in Madagascar?
Your response must be concise. 72.85. What is the difference between the highest and the lowest Gross intake ratio(%) of Vietnam?
Provide a succinct answer. 8.27. 